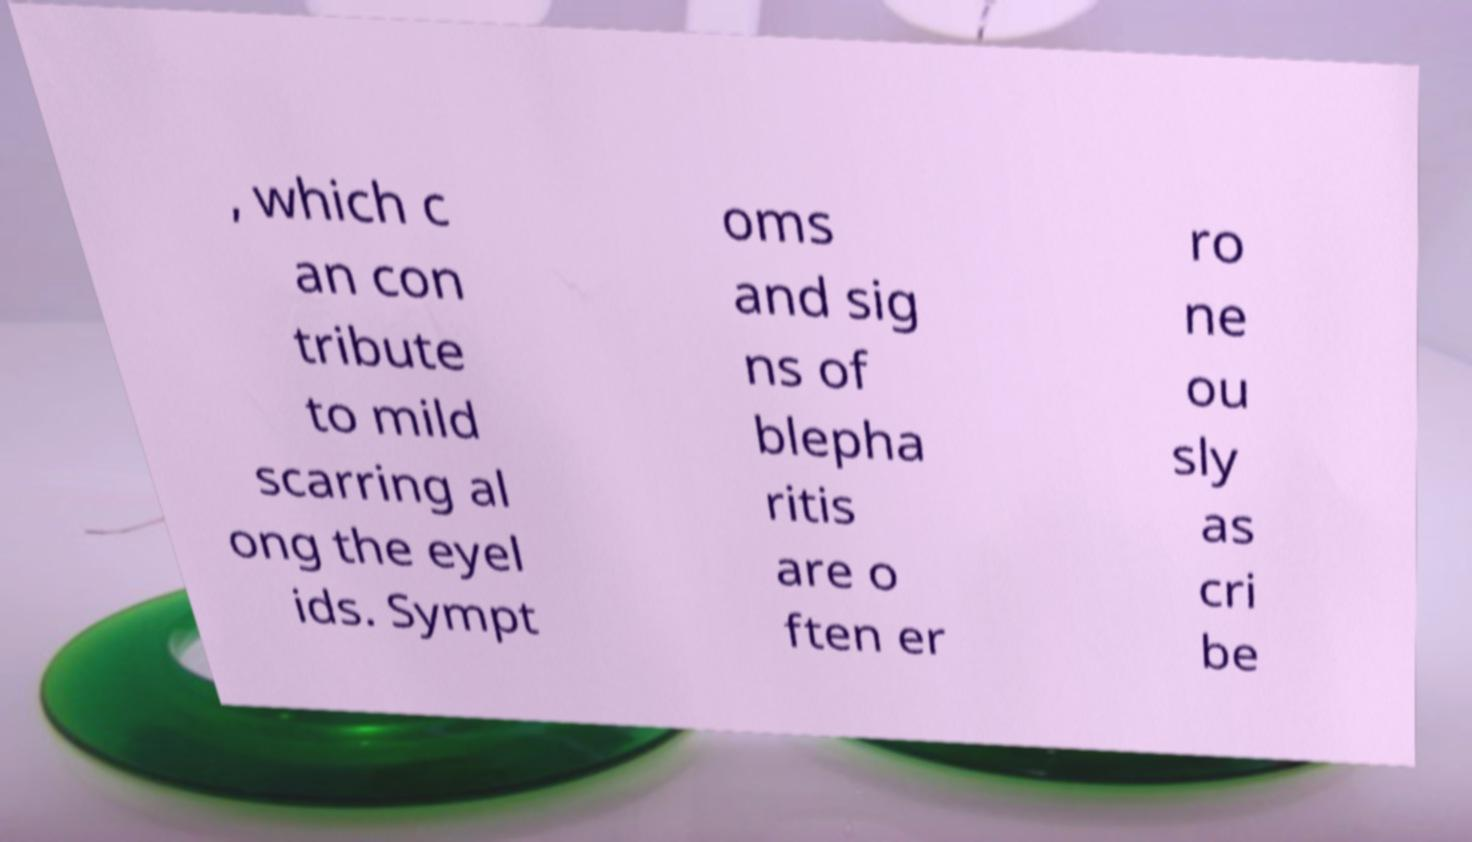I need the written content from this picture converted into text. Can you do that? , which c an con tribute to mild scarring al ong the eyel ids. Sympt oms and sig ns of blepha ritis are o ften er ro ne ou sly as cri be 